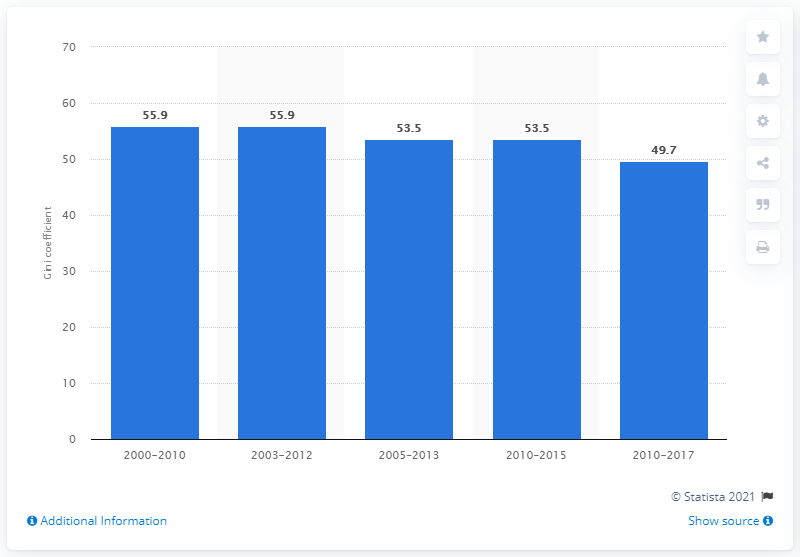Point out several critical features in this image. In 2017, the Gini coefficient in Colombia was 49.7, indicating a high level of income inequality in the country. 